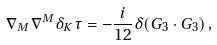Convert formula to latex. <formula><loc_0><loc_0><loc_500><loc_500>\nabla _ { M } \nabla ^ { M } \delta _ { K } \tau = - \frac { i } { 1 2 } \delta ( G _ { 3 } \cdot G _ { 3 } ) \, ,</formula> 